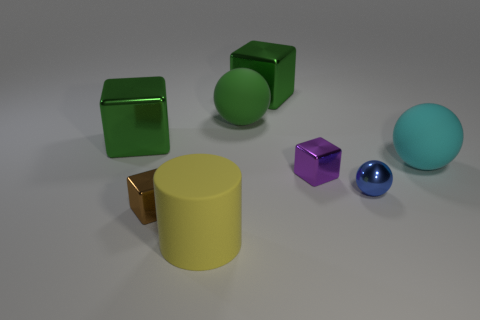Can you describe the texture of the objects in the image? Certainly! The objects in the image appear to have two main textures. The cubes and the cylinder have a matte surface suggesting a soft, diffuse reflection, while the sphere and the smaller, shiny object are reflective and smooth, indicative of a metallic or polished surface. 